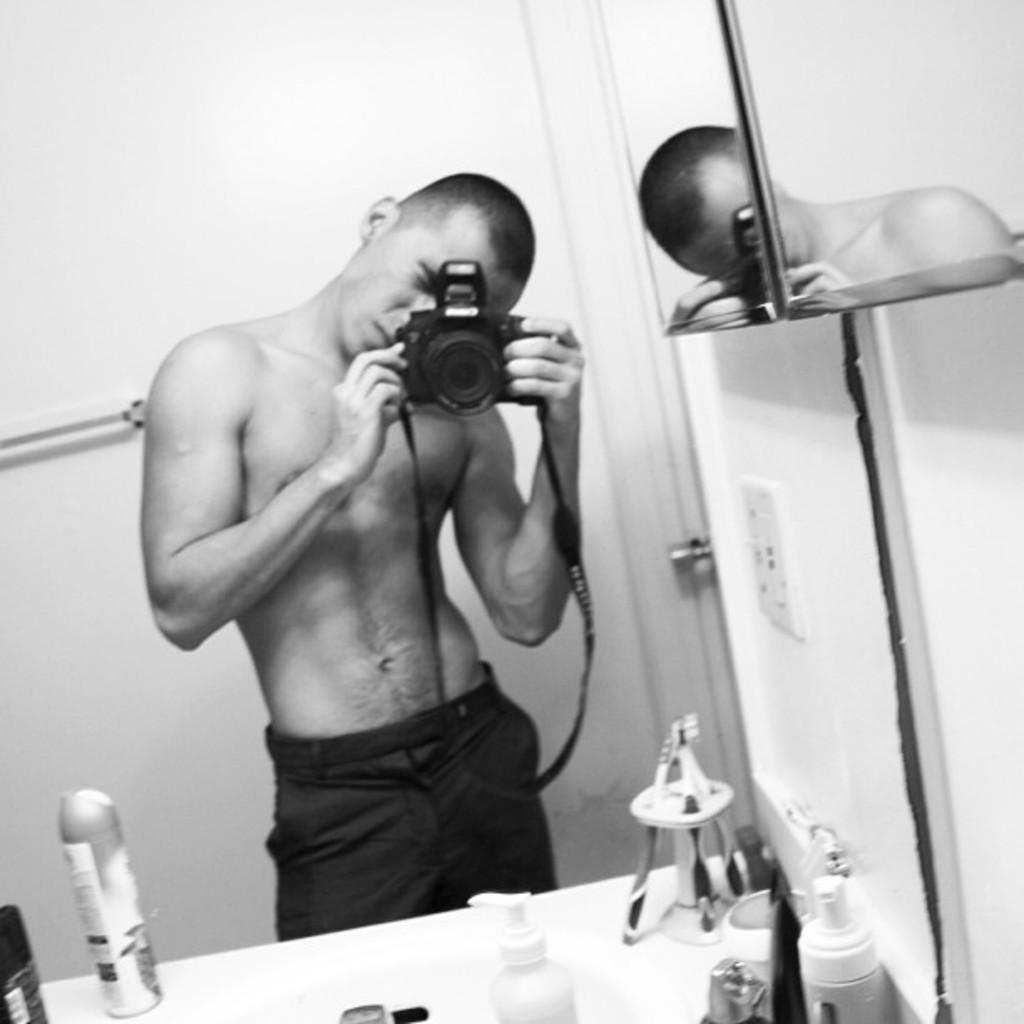Could you give a brief overview of what you see in this image? In the middle of the image we can see a man, he is holding a camera and he is standing in front of the mirror, in front of him we can see few bottles, brushes and other things, it is a black and white photograph. 